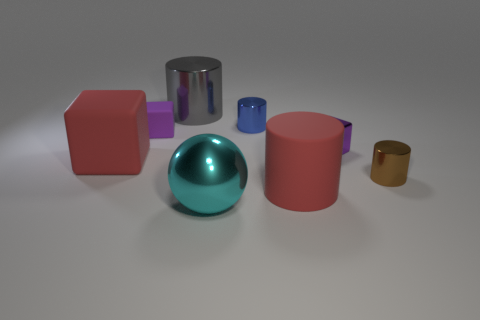Subtract all red matte cubes. How many cubes are left? 2 Subtract all gray cylinders. How many cylinders are left? 3 Subtract all yellow spheres. How many purple blocks are left? 2 Add 1 tiny metallic cylinders. How many objects exist? 9 Subtract all gray blocks. Subtract all cyan cylinders. How many blocks are left? 3 Subtract 0 gray blocks. How many objects are left? 8 Subtract all spheres. How many objects are left? 7 Subtract all large rubber cylinders. Subtract all tiny purple rubber blocks. How many objects are left? 6 Add 1 objects. How many objects are left? 9 Add 7 big blocks. How many big blocks exist? 8 